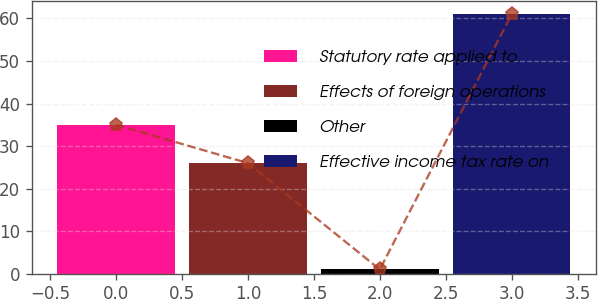<chart> <loc_0><loc_0><loc_500><loc_500><bar_chart><fcel>Statutory rate applied to<fcel>Effects of foreign operations<fcel>Other<fcel>Effective income tax rate on<nl><fcel>35<fcel>26<fcel>1<fcel>61<nl></chart> 